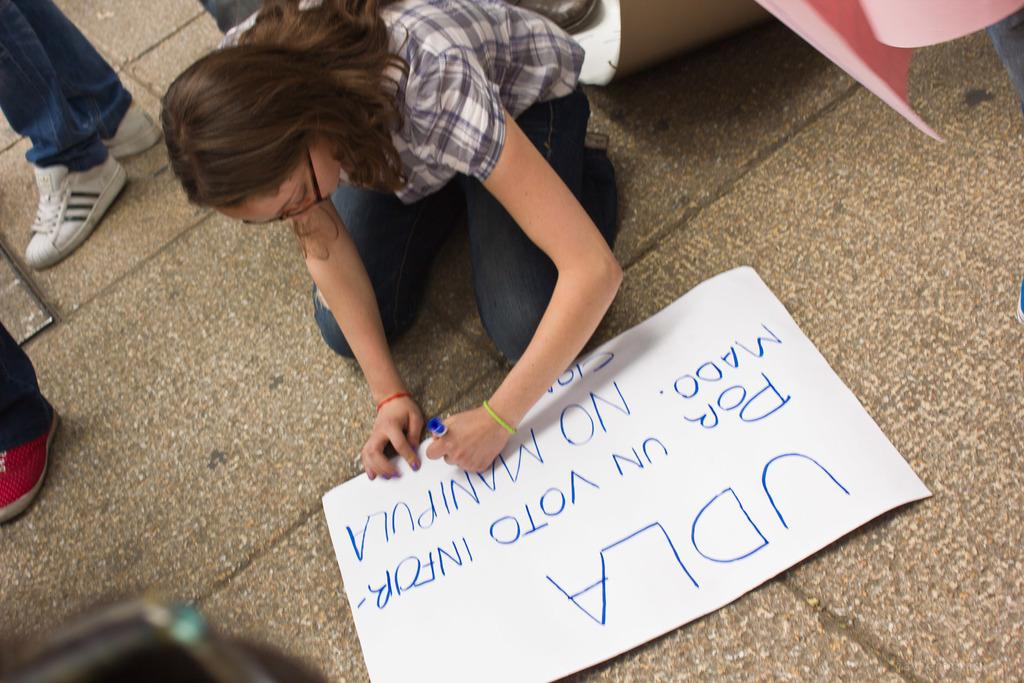Who is the main subject in the image? There is a girl in the image. What is the girl doing in the image? The girl is kneeling on the floor and writing on a white sheet. What is the position of the girl's legs in the image? The girl is on her knee. Are there any other people present in the image? Yes, there are people standing around the girl. What shape does the girl's tongue make while she is writing on the white sheet? There is no information about the girl's tongue in the image, so we cannot determine its shape. 